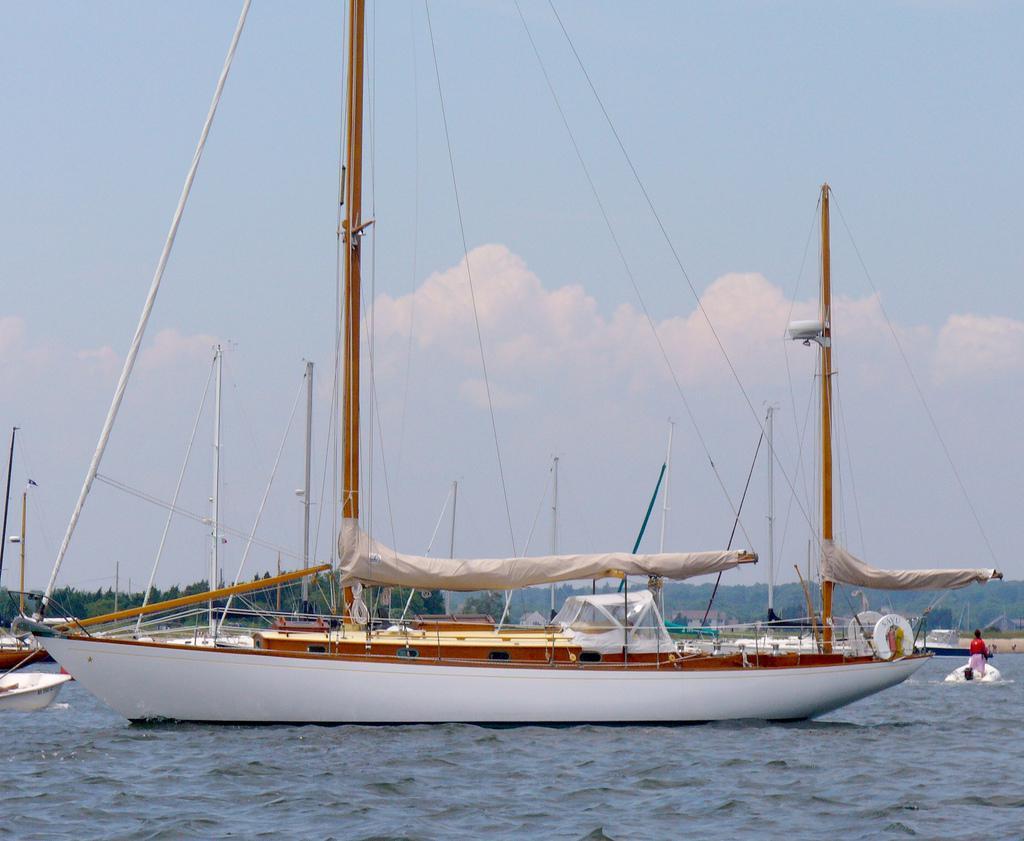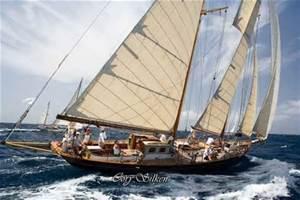The first image is the image on the left, the second image is the image on the right. For the images displayed, is the sentence "The sailboat in the right image is tipped rightward, showing its interior." factually correct? Answer yes or no. Yes. The first image is the image on the left, the second image is the image on the right. Examine the images to the left and right. Is the description "One boat only has two sails unfurled." accurate? Answer yes or no. No. 